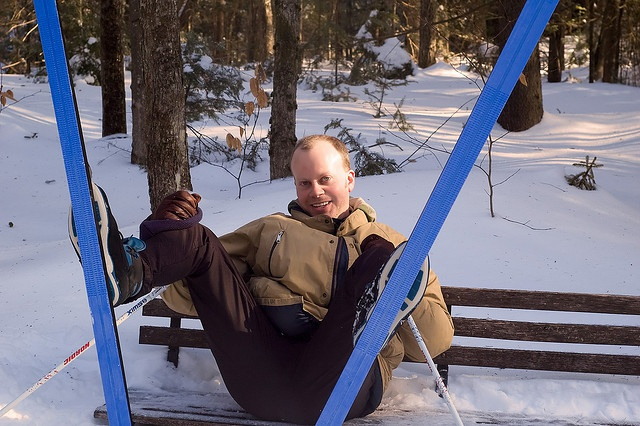Describe the objects in this image and their specific colors. I can see people in black, gray, maroon, and darkgray tones, bench in black, darkgray, and gray tones, and skis in black and blue tones in this image. 